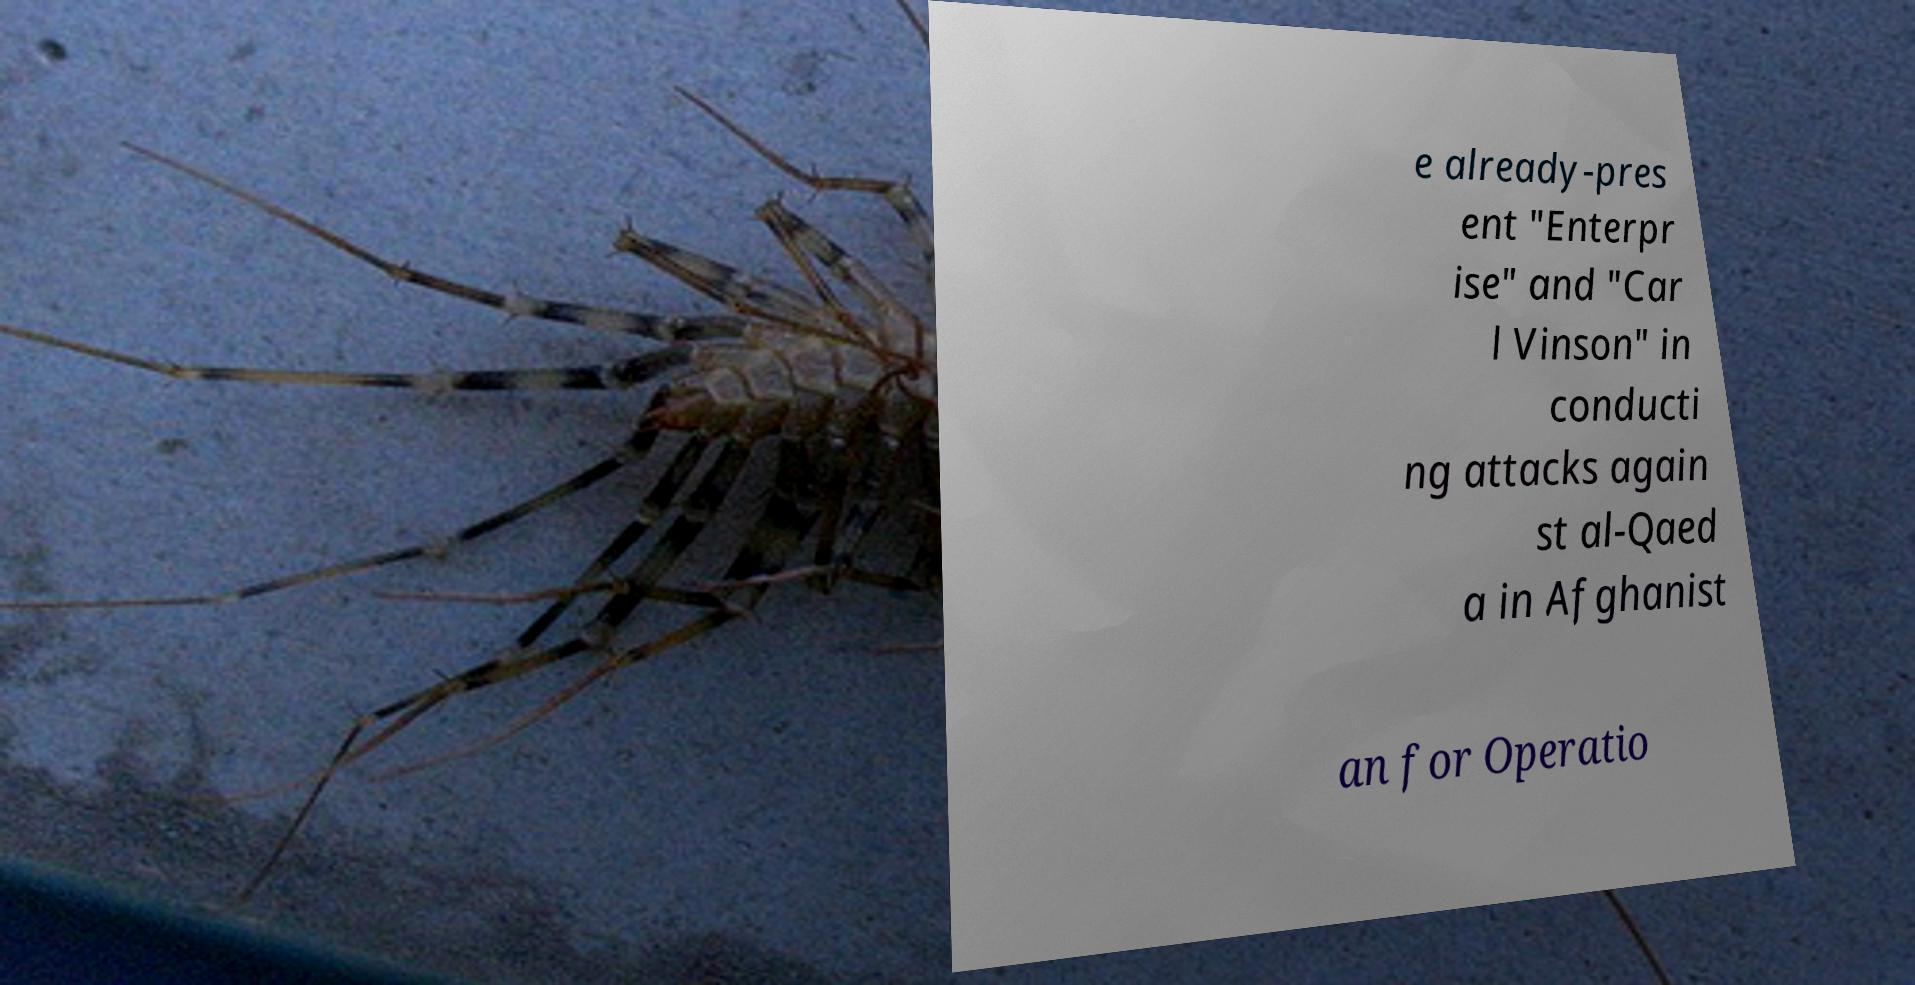Can you accurately transcribe the text from the provided image for me? e already-pres ent "Enterpr ise" and "Car l Vinson" in conducti ng attacks again st al-Qaed a in Afghanist an for Operatio 